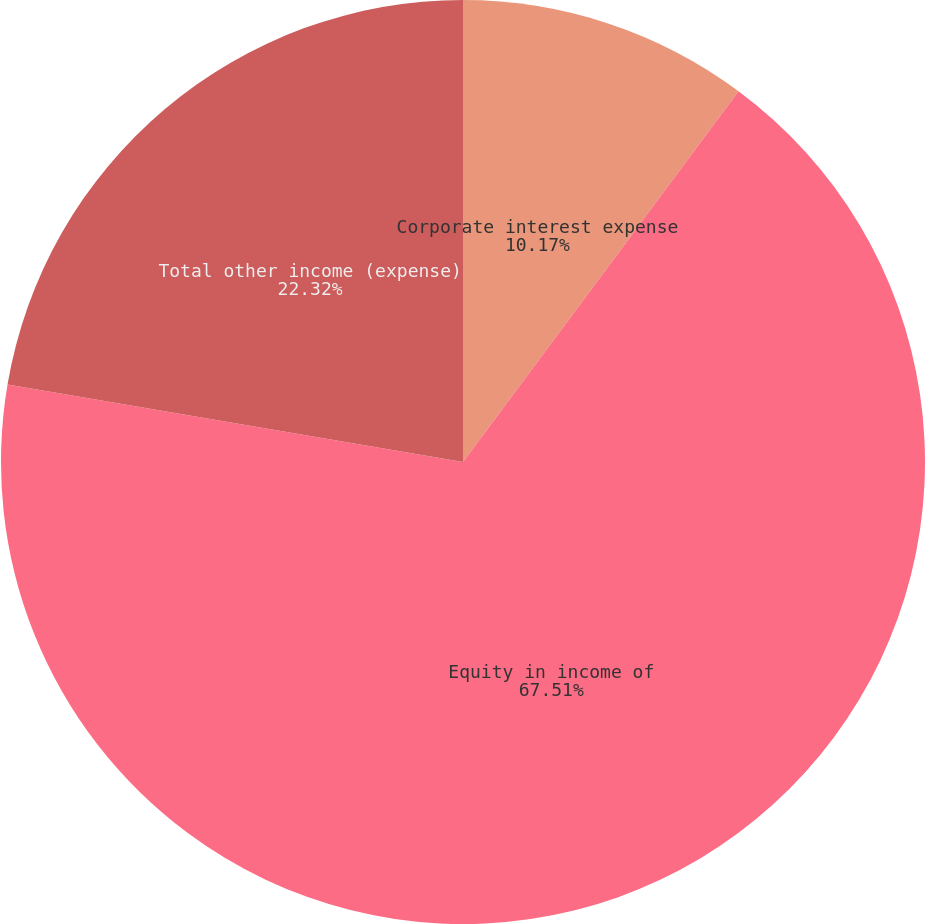Convert chart to OTSL. <chart><loc_0><loc_0><loc_500><loc_500><pie_chart><fcel>Corporate interest expense<fcel>Equity in income of<fcel>Total other income (expense)<nl><fcel>10.17%<fcel>67.51%<fcel>22.32%<nl></chart> 